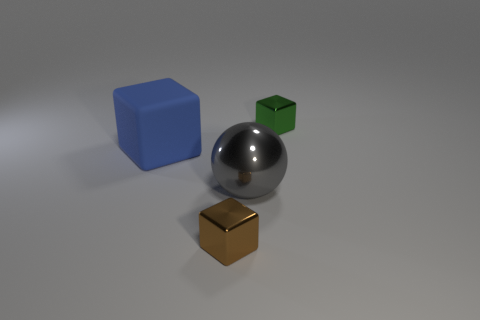What is the material of the small block to the left of the gray ball?
Make the answer very short. Metal. Is there anything else of the same color as the rubber object?
Offer a very short reply. No. The green block that is the same material as the big gray ball is what size?
Keep it short and to the point. Small. What number of large things are either brown objects or metal blocks?
Ensure brevity in your answer.  0. There is a block that is in front of the big object on the right side of the cube in front of the blue rubber cube; how big is it?
Offer a terse response. Small. How many other blocks have the same size as the brown block?
Your response must be concise. 1. What number of things are tiny green metallic things or metallic cubes that are in front of the green object?
Keep it short and to the point. 2. The large metallic thing has what shape?
Offer a very short reply. Sphere. Do the matte cube and the big ball have the same color?
Provide a succinct answer. No. There is a ball that is the same size as the blue rubber cube; what color is it?
Offer a terse response. Gray. 